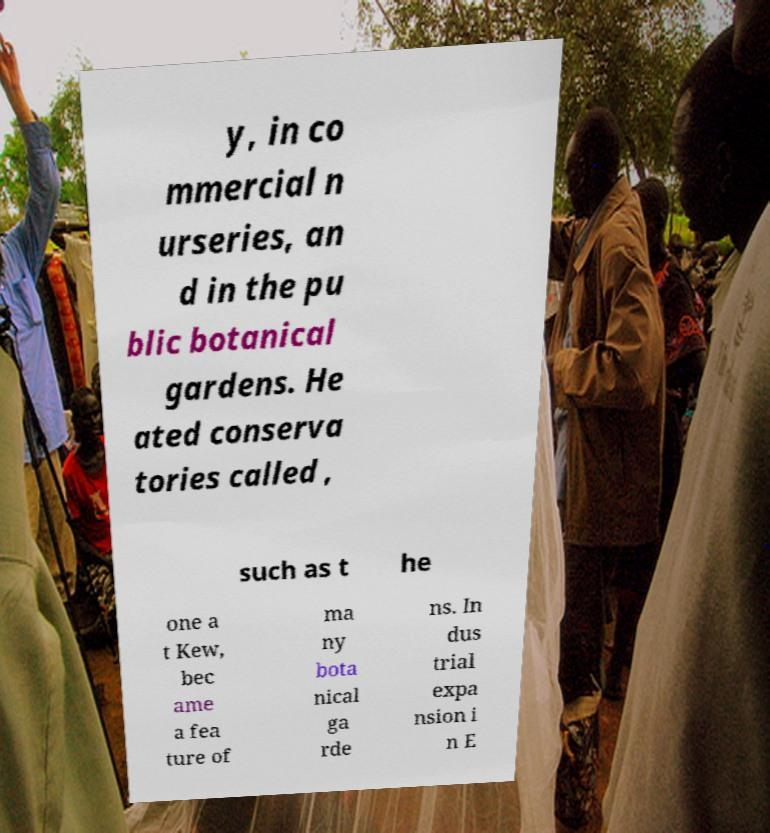Can you read and provide the text displayed in the image?This photo seems to have some interesting text. Can you extract and type it out for me? y, in co mmercial n urseries, an d in the pu blic botanical gardens. He ated conserva tories called , such as t he one a t Kew, bec ame a fea ture of ma ny bota nical ga rde ns. In dus trial expa nsion i n E 